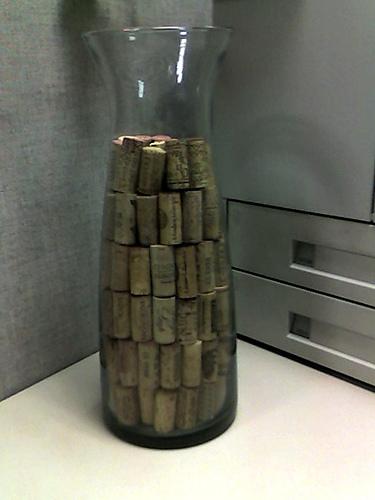What is in the jar?
Keep it brief. Corks. Is the vase transparent?
Be succinct. Yes. How many wine corks do you see?
Be succinct. 40. What is in the vase?
Short answer required. Corks. 